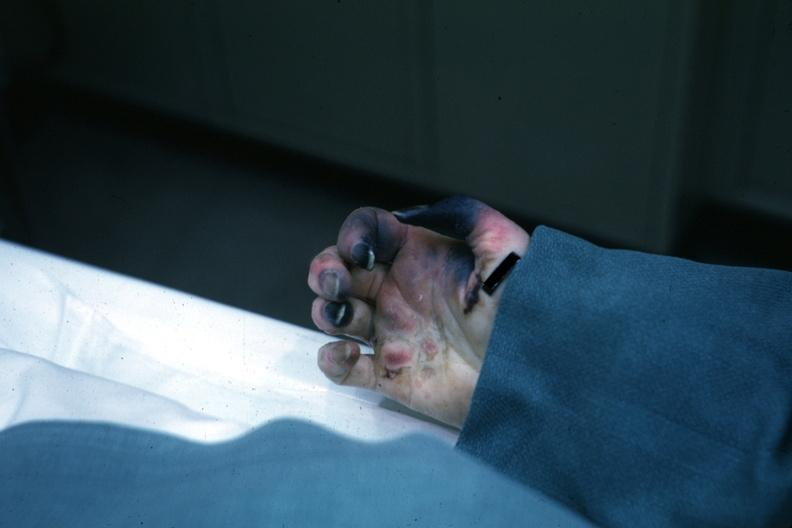what know shock vs emboli?
Answer the question using a single word or phrase. Obvious gangrenous necrosis child with congenital heart disease post op exact cause 